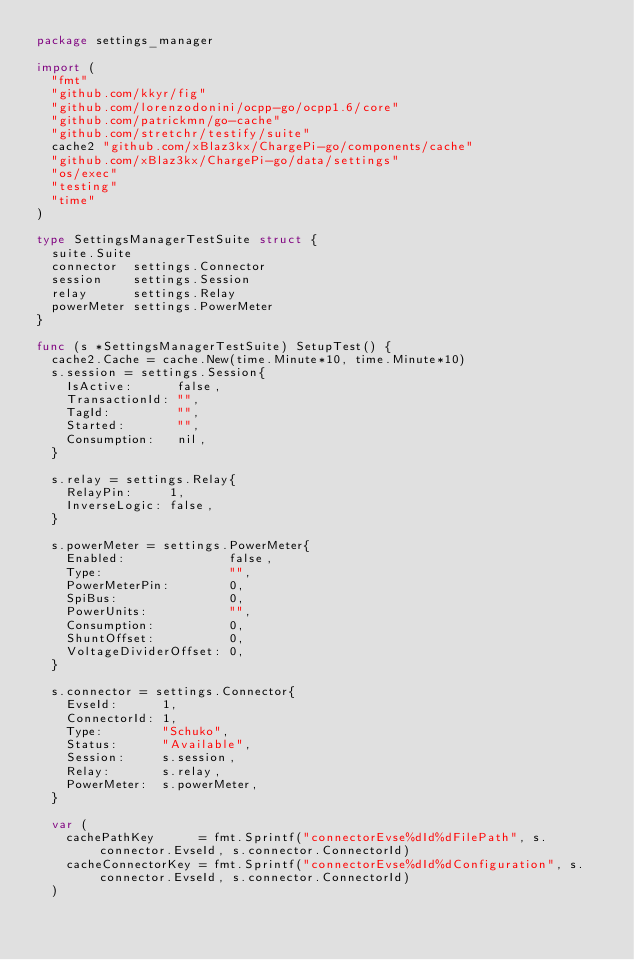<code> <loc_0><loc_0><loc_500><loc_500><_Go_>package settings_manager

import (
	"fmt"
	"github.com/kkyr/fig"
	"github.com/lorenzodonini/ocpp-go/ocpp1.6/core"
	"github.com/patrickmn/go-cache"
	"github.com/stretchr/testify/suite"
	cache2 "github.com/xBlaz3kx/ChargePi-go/components/cache"
	"github.com/xBlaz3kx/ChargePi-go/data/settings"
	"os/exec"
	"testing"
	"time"
)

type SettingsManagerTestSuite struct {
	suite.Suite
	connector  settings.Connector
	session    settings.Session
	relay      settings.Relay
	powerMeter settings.PowerMeter
}

func (s *SettingsManagerTestSuite) SetupTest() {
	cache2.Cache = cache.New(time.Minute*10, time.Minute*10)
	s.session = settings.Session{
		IsActive:      false,
		TransactionId: "",
		TagId:         "",
		Started:       "",
		Consumption:   nil,
	}

	s.relay = settings.Relay{
		RelayPin:     1,
		InverseLogic: false,
	}

	s.powerMeter = settings.PowerMeter{
		Enabled:              false,
		Type:                 "",
		PowerMeterPin:        0,
		SpiBus:               0,
		PowerUnits:           "",
		Consumption:          0,
		ShuntOffset:          0,
		VoltageDividerOffset: 0,
	}

	s.connector = settings.Connector{
		EvseId:      1,
		ConnectorId: 1,
		Type:        "Schuko",
		Status:      "Available",
		Session:     s.session,
		Relay:       s.relay,
		PowerMeter:  s.powerMeter,
	}

	var (
		cachePathKey      = fmt.Sprintf("connectorEvse%dId%dFilePath", s.connector.EvseId, s.connector.ConnectorId)
		cacheConnectorKey = fmt.Sprintf("connectorEvse%dId%dConfiguration", s.connector.EvseId, s.connector.ConnectorId)
	)
</code> 